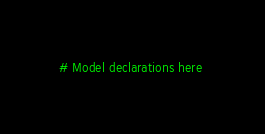<code> <loc_0><loc_0><loc_500><loc_500><_Julia_># Model declarations here 
</code> 